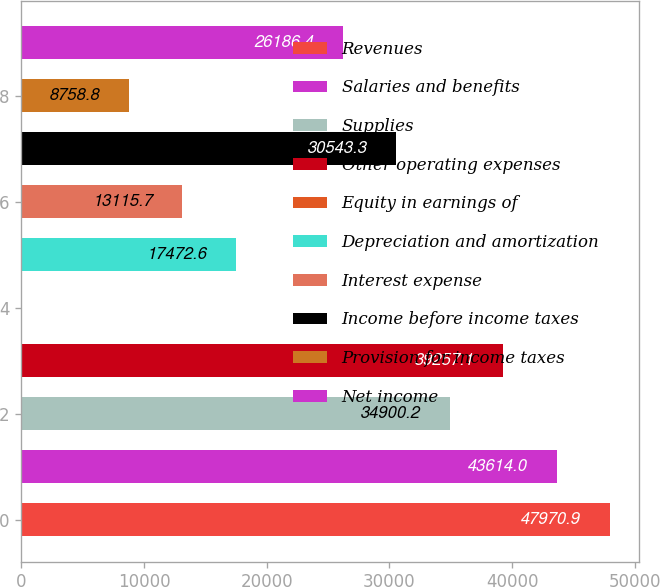Convert chart. <chart><loc_0><loc_0><loc_500><loc_500><bar_chart><fcel>Revenues<fcel>Salaries and benefits<fcel>Supplies<fcel>Other operating expenses<fcel>Equity in earnings of<fcel>Depreciation and amortization<fcel>Interest expense<fcel>Income before income taxes<fcel>Provision for income taxes<fcel>Net income<nl><fcel>47970.9<fcel>43614<fcel>34900.2<fcel>39257.1<fcel>45<fcel>17472.6<fcel>13115.7<fcel>30543.3<fcel>8758.8<fcel>26186.4<nl></chart> 